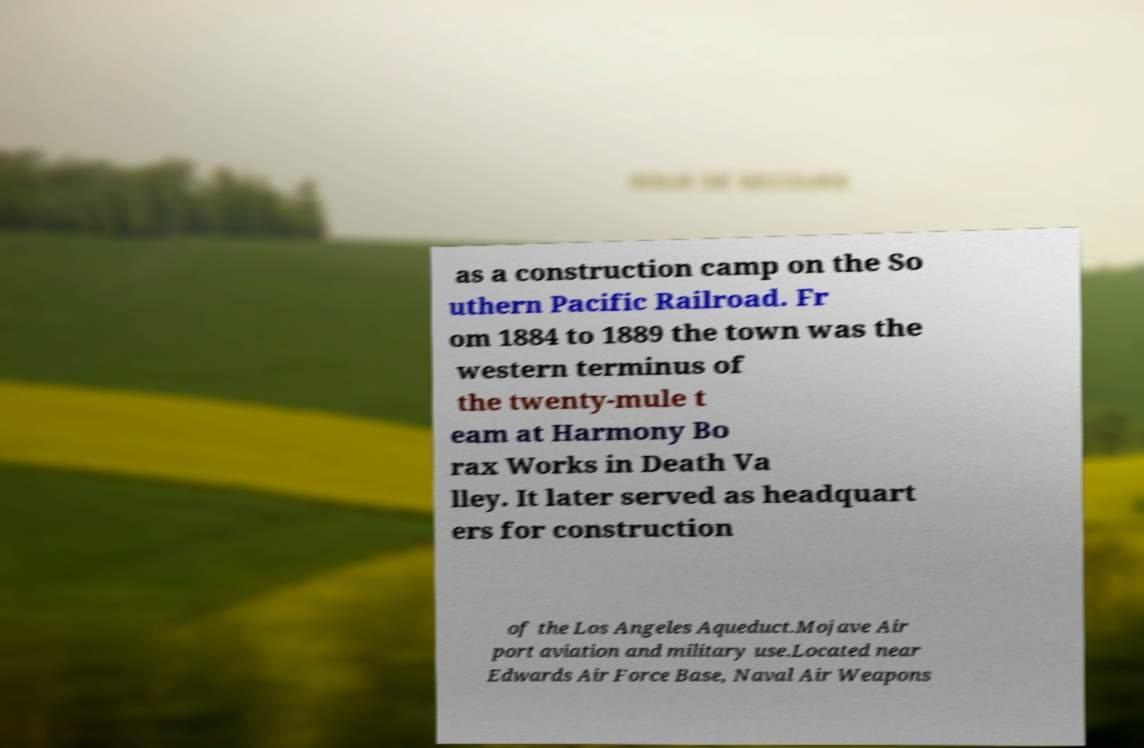There's text embedded in this image that I need extracted. Can you transcribe it verbatim? as a construction camp on the So uthern Pacific Railroad. Fr om 1884 to 1889 the town was the western terminus of the twenty-mule t eam at Harmony Bo rax Works in Death Va lley. It later served as headquart ers for construction of the Los Angeles Aqueduct.Mojave Air port aviation and military use.Located near Edwards Air Force Base, Naval Air Weapons 